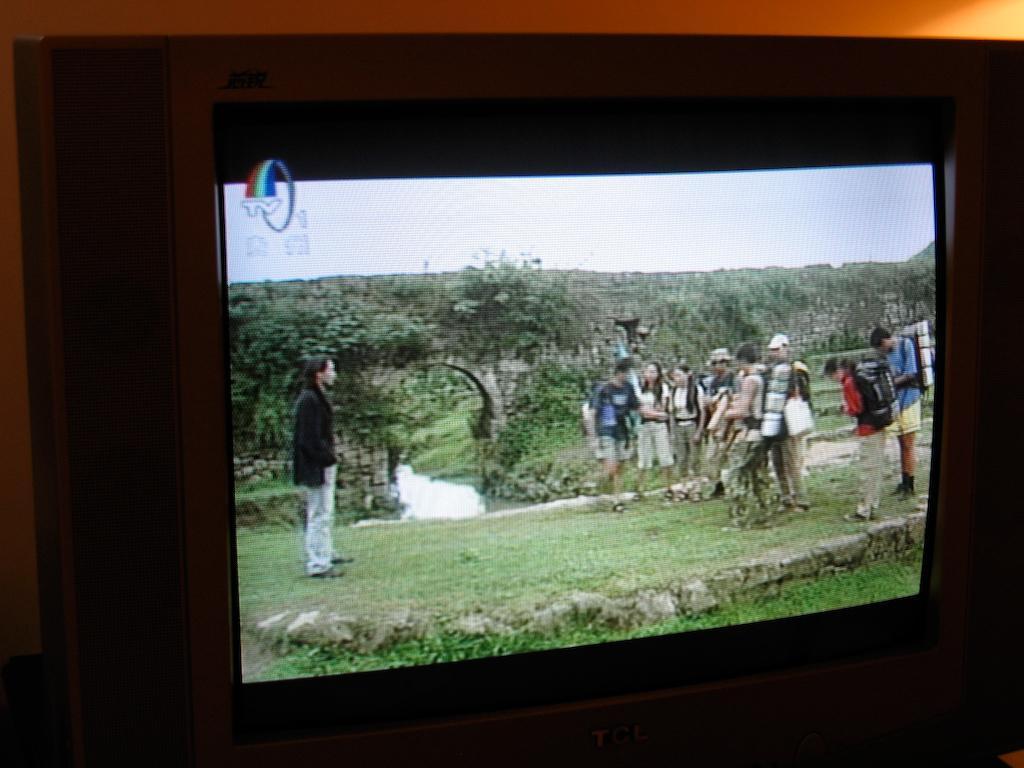Please provide a concise description of this image. The picture consists of a television, in the television we can see people, plants, trees, grass, bridge and water body. At the top there is sky. In the picture at the top we can see an object looking like a wall. 